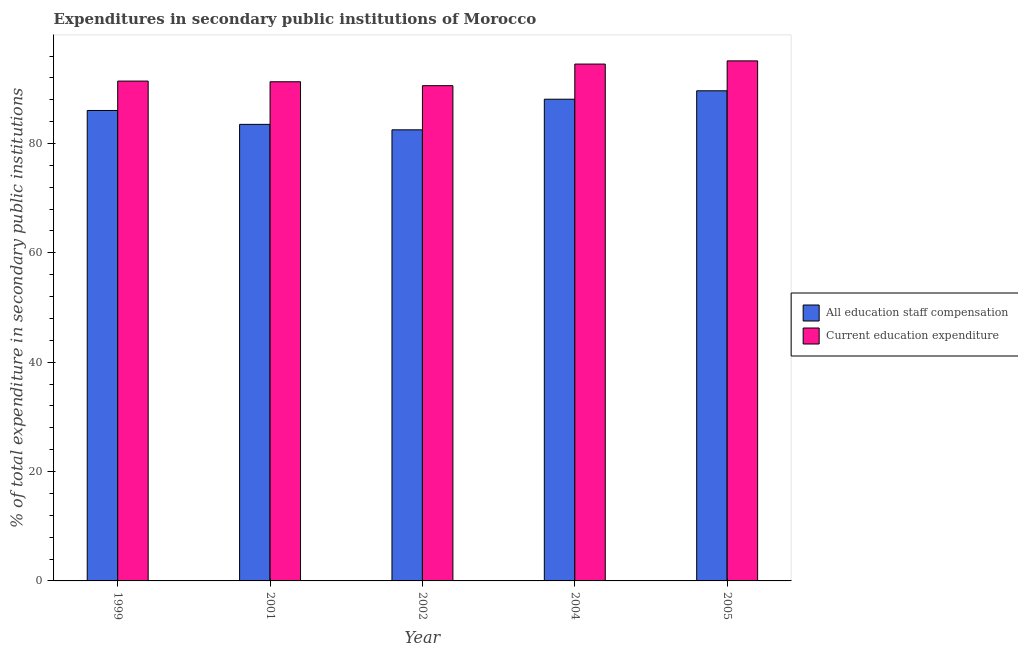How many different coloured bars are there?
Provide a short and direct response. 2. How many groups of bars are there?
Your response must be concise. 5. Are the number of bars on each tick of the X-axis equal?
Offer a very short reply. Yes. How many bars are there on the 5th tick from the left?
Your answer should be very brief. 2. How many bars are there on the 5th tick from the right?
Keep it short and to the point. 2. What is the expenditure in staff compensation in 2004?
Your response must be concise. 88.1. Across all years, what is the maximum expenditure in staff compensation?
Provide a succinct answer. 89.64. Across all years, what is the minimum expenditure in staff compensation?
Provide a succinct answer. 82.5. What is the total expenditure in staff compensation in the graph?
Give a very brief answer. 429.78. What is the difference between the expenditure in staff compensation in 2001 and that in 2002?
Ensure brevity in your answer.  1. What is the difference between the expenditure in education in 2005 and the expenditure in staff compensation in 2002?
Provide a short and direct response. 4.54. What is the average expenditure in staff compensation per year?
Your response must be concise. 85.96. In how many years, is the expenditure in education greater than 92 %?
Your answer should be compact. 2. What is the ratio of the expenditure in education in 1999 to that in 2001?
Your answer should be compact. 1. What is the difference between the highest and the second highest expenditure in education?
Keep it short and to the point. 0.58. What is the difference between the highest and the lowest expenditure in education?
Offer a very short reply. 4.54. In how many years, is the expenditure in education greater than the average expenditure in education taken over all years?
Make the answer very short. 2. Is the sum of the expenditure in education in 2002 and 2004 greater than the maximum expenditure in staff compensation across all years?
Make the answer very short. Yes. What does the 2nd bar from the left in 1999 represents?
Provide a succinct answer. Current education expenditure. What does the 2nd bar from the right in 2005 represents?
Offer a very short reply. All education staff compensation. Are all the bars in the graph horizontal?
Your answer should be compact. No. Are the values on the major ticks of Y-axis written in scientific E-notation?
Your answer should be compact. No. Does the graph contain any zero values?
Your response must be concise. No. Where does the legend appear in the graph?
Offer a terse response. Center right. How many legend labels are there?
Make the answer very short. 2. What is the title of the graph?
Make the answer very short. Expenditures in secondary public institutions of Morocco. Does "Urban Population" appear as one of the legend labels in the graph?
Offer a very short reply. No. What is the label or title of the Y-axis?
Provide a succinct answer. % of total expenditure in secondary public institutions. What is the % of total expenditure in secondary public institutions of All education staff compensation in 1999?
Give a very brief answer. 86.04. What is the % of total expenditure in secondary public institutions of Current education expenditure in 1999?
Provide a short and direct response. 91.41. What is the % of total expenditure in secondary public institutions of All education staff compensation in 2001?
Your response must be concise. 83.5. What is the % of total expenditure in secondary public institutions in Current education expenditure in 2001?
Your answer should be compact. 91.29. What is the % of total expenditure in secondary public institutions in All education staff compensation in 2002?
Offer a terse response. 82.5. What is the % of total expenditure in secondary public institutions of Current education expenditure in 2002?
Give a very brief answer. 90.57. What is the % of total expenditure in secondary public institutions of All education staff compensation in 2004?
Provide a succinct answer. 88.1. What is the % of total expenditure in secondary public institutions in Current education expenditure in 2004?
Offer a very short reply. 94.53. What is the % of total expenditure in secondary public institutions of All education staff compensation in 2005?
Keep it short and to the point. 89.64. What is the % of total expenditure in secondary public institutions of Current education expenditure in 2005?
Offer a terse response. 95.11. Across all years, what is the maximum % of total expenditure in secondary public institutions in All education staff compensation?
Provide a succinct answer. 89.64. Across all years, what is the maximum % of total expenditure in secondary public institutions in Current education expenditure?
Your response must be concise. 95.11. Across all years, what is the minimum % of total expenditure in secondary public institutions in All education staff compensation?
Your response must be concise. 82.5. Across all years, what is the minimum % of total expenditure in secondary public institutions of Current education expenditure?
Your answer should be very brief. 90.57. What is the total % of total expenditure in secondary public institutions of All education staff compensation in the graph?
Your response must be concise. 429.78. What is the total % of total expenditure in secondary public institutions of Current education expenditure in the graph?
Offer a terse response. 462.91. What is the difference between the % of total expenditure in secondary public institutions in All education staff compensation in 1999 and that in 2001?
Give a very brief answer. 2.54. What is the difference between the % of total expenditure in secondary public institutions of Current education expenditure in 1999 and that in 2001?
Your answer should be compact. 0.12. What is the difference between the % of total expenditure in secondary public institutions in All education staff compensation in 1999 and that in 2002?
Provide a succinct answer. 3.54. What is the difference between the % of total expenditure in secondary public institutions in Current education expenditure in 1999 and that in 2002?
Make the answer very short. 0.84. What is the difference between the % of total expenditure in secondary public institutions in All education staff compensation in 1999 and that in 2004?
Offer a terse response. -2.06. What is the difference between the % of total expenditure in secondary public institutions of Current education expenditure in 1999 and that in 2004?
Ensure brevity in your answer.  -3.11. What is the difference between the % of total expenditure in secondary public institutions of All education staff compensation in 1999 and that in 2005?
Provide a succinct answer. -3.6. What is the difference between the % of total expenditure in secondary public institutions in Current education expenditure in 1999 and that in 2005?
Offer a terse response. -3.7. What is the difference between the % of total expenditure in secondary public institutions of Current education expenditure in 2001 and that in 2002?
Make the answer very short. 0.72. What is the difference between the % of total expenditure in secondary public institutions in All education staff compensation in 2001 and that in 2004?
Your response must be concise. -4.6. What is the difference between the % of total expenditure in secondary public institutions in Current education expenditure in 2001 and that in 2004?
Offer a terse response. -3.24. What is the difference between the % of total expenditure in secondary public institutions of All education staff compensation in 2001 and that in 2005?
Provide a short and direct response. -6.14. What is the difference between the % of total expenditure in secondary public institutions of Current education expenditure in 2001 and that in 2005?
Your answer should be compact. -3.82. What is the difference between the % of total expenditure in secondary public institutions in All education staff compensation in 2002 and that in 2004?
Your answer should be compact. -5.6. What is the difference between the % of total expenditure in secondary public institutions in Current education expenditure in 2002 and that in 2004?
Keep it short and to the point. -3.95. What is the difference between the % of total expenditure in secondary public institutions of All education staff compensation in 2002 and that in 2005?
Offer a very short reply. -7.14. What is the difference between the % of total expenditure in secondary public institutions in Current education expenditure in 2002 and that in 2005?
Your response must be concise. -4.54. What is the difference between the % of total expenditure in secondary public institutions of All education staff compensation in 2004 and that in 2005?
Make the answer very short. -1.54. What is the difference between the % of total expenditure in secondary public institutions of Current education expenditure in 2004 and that in 2005?
Ensure brevity in your answer.  -0.58. What is the difference between the % of total expenditure in secondary public institutions of All education staff compensation in 1999 and the % of total expenditure in secondary public institutions of Current education expenditure in 2001?
Your answer should be very brief. -5.25. What is the difference between the % of total expenditure in secondary public institutions in All education staff compensation in 1999 and the % of total expenditure in secondary public institutions in Current education expenditure in 2002?
Your response must be concise. -4.53. What is the difference between the % of total expenditure in secondary public institutions in All education staff compensation in 1999 and the % of total expenditure in secondary public institutions in Current education expenditure in 2004?
Keep it short and to the point. -8.49. What is the difference between the % of total expenditure in secondary public institutions of All education staff compensation in 1999 and the % of total expenditure in secondary public institutions of Current education expenditure in 2005?
Provide a short and direct response. -9.07. What is the difference between the % of total expenditure in secondary public institutions in All education staff compensation in 2001 and the % of total expenditure in secondary public institutions in Current education expenditure in 2002?
Make the answer very short. -7.07. What is the difference between the % of total expenditure in secondary public institutions of All education staff compensation in 2001 and the % of total expenditure in secondary public institutions of Current education expenditure in 2004?
Keep it short and to the point. -11.03. What is the difference between the % of total expenditure in secondary public institutions of All education staff compensation in 2001 and the % of total expenditure in secondary public institutions of Current education expenditure in 2005?
Ensure brevity in your answer.  -11.61. What is the difference between the % of total expenditure in secondary public institutions in All education staff compensation in 2002 and the % of total expenditure in secondary public institutions in Current education expenditure in 2004?
Provide a succinct answer. -12.02. What is the difference between the % of total expenditure in secondary public institutions in All education staff compensation in 2002 and the % of total expenditure in secondary public institutions in Current education expenditure in 2005?
Provide a short and direct response. -12.61. What is the difference between the % of total expenditure in secondary public institutions of All education staff compensation in 2004 and the % of total expenditure in secondary public institutions of Current education expenditure in 2005?
Provide a succinct answer. -7.01. What is the average % of total expenditure in secondary public institutions of All education staff compensation per year?
Offer a terse response. 85.96. What is the average % of total expenditure in secondary public institutions in Current education expenditure per year?
Make the answer very short. 92.58. In the year 1999, what is the difference between the % of total expenditure in secondary public institutions of All education staff compensation and % of total expenditure in secondary public institutions of Current education expenditure?
Ensure brevity in your answer.  -5.38. In the year 2001, what is the difference between the % of total expenditure in secondary public institutions of All education staff compensation and % of total expenditure in secondary public institutions of Current education expenditure?
Your response must be concise. -7.79. In the year 2002, what is the difference between the % of total expenditure in secondary public institutions of All education staff compensation and % of total expenditure in secondary public institutions of Current education expenditure?
Your answer should be very brief. -8.07. In the year 2004, what is the difference between the % of total expenditure in secondary public institutions of All education staff compensation and % of total expenditure in secondary public institutions of Current education expenditure?
Ensure brevity in your answer.  -6.43. In the year 2005, what is the difference between the % of total expenditure in secondary public institutions in All education staff compensation and % of total expenditure in secondary public institutions in Current education expenditure?
Provide a succinct answer. -5.47. What is the ratio of the % of total expenditure in secondary public institutions in All education staff compensation in 1999 to that in 2001?
Ensure brevity in your answer.  1.03. What is the ratio of the % of total expenditure in secondary public institutions of All education staff compensation in 1999 to that in 2002?
Your response must be concise. 1.04. What is the ratio of the % of total expenditure in secondary public institutions of Current education expenditure in 1999 to that in 2002?
Offer a very short reply. 1.01. What is the ratio of the % of total expenditure in secondary public institutions of All education staff compensation in 1999 to that in 2004?
Offer a very short reply. 0.98. What is the ratio of the % of total expenditure in secondary public institutions in Current education expenditure in 1999 to that in 2004?
Your response must be concise. 0.97. What is the ratio of the % of total expenditure in secondary public institutions of All education staff compensation in 1999 to that in 2005?
Offer a very short reply. 0.96. What is the ratio of the % of total expenditure in secondary public institutions in Current education expenditure in 1999 to that in 2005?
Provide a succinct answer. 0.96. What is the ratio of the % of total expenditure in secondary public institutions in All education staff compensation in 2001 to that in 2002?
Your answer should be very brief. 1.01. What is the ratio of the % of total expenditure in secondary public institutions in Current education expenditure in 2001 to that in 2002?
Offer a very short reply. 1.01. What is the ratio of the % of total expenditure in secondary public institutions in All education staff compensation in 2001 to that in 2004?
Provide a succinct answer. 0.95. What is the ratio of the % of total expenditure in secondary public institutions of Current education expenditure in 2001 to that in 2004?
Your answer should be very brief. 0.97. What is the ratio of the % of total expenditure in secondary public institutions of All education staff compensation in 2001 to that in 2005?
Make the answer very short. 0.93. What is the ratio of the % of total expenditure in secondary public institutions of Current education expenditure in 2001 to that in 2005?
Your answer should be very brief. 0.96. What is the ratio of the % of total expenditure in secondary public institutions of All education staff compensation in 2002 to that in 2004?
Your response must be concise. 0.94. What is the ratio of the % of total expenditure in secondary public institutions in Current education expenditure in 2002 to that in 2004?
Make the answer very short. 0.96. What is the ratio of the % of total expenditure in secondary public institutions in All education staff compensation in 2002 to that in 2005?
Provide a succinct answer. 0.92. What is the ratio of the % of total expenditure in secondary public institutions of Current education expenditure in 2002 to that in 2005?
Offer a terse response. 0.95. What is the ratio of the % of total expenditure in secondary public institutions in All education staff compensation in 2004 to that in 2005?
Provide a short and direct response. 0.98. What is the difference between the highest and the second highest % of total expenditure in secondary public institutions in All education staff compensation?
Your answer should be very brief. 1.54. What is the difference between the highest and the second highest % of total expenditure in secondary public institutions of Current education expenditure?
Keep it short and to the point. 0.58. What is the difference between the highest and the lowest % of total expenditure in secondary public institutions of All education staff compensation?
Provide a short and direct response. 7.14. What is the difference between the highest and the lowest % of total expenditure in secondary public institutions of Current education expenditure?
Make the answer very short. 4.54. 